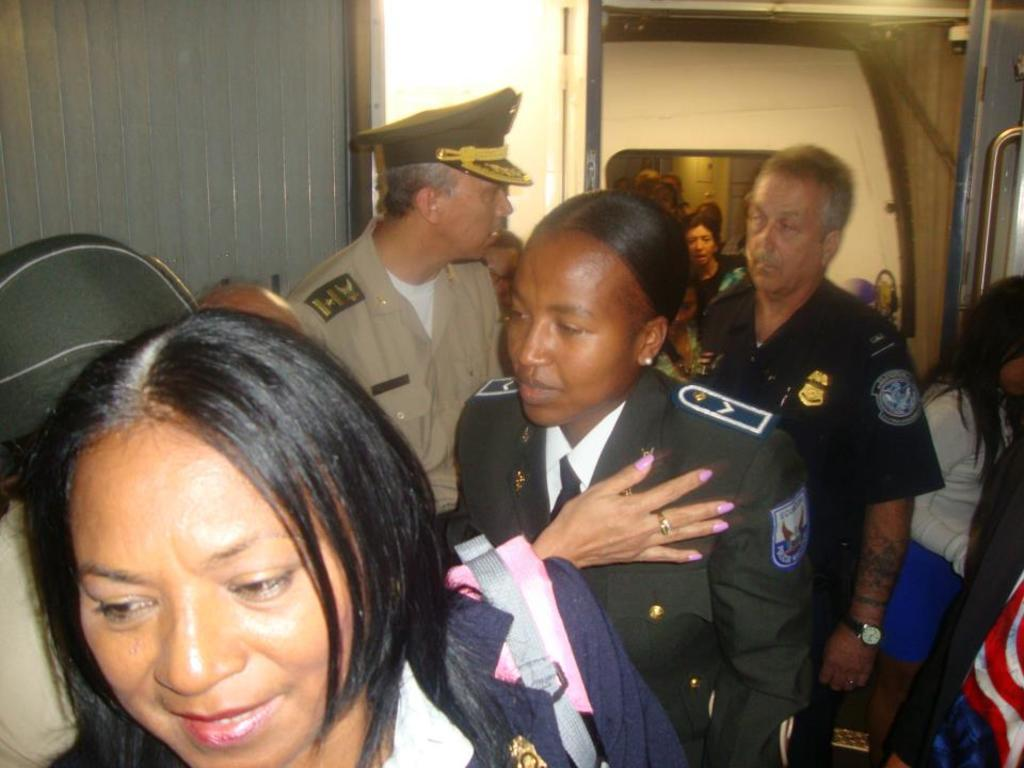Who or what can be seen in the image? There are people in the image. What architectural feature is present in the image? There is a door in the image. How many rings are visible on the door in the image? There are no rings visible on the door in the image. 